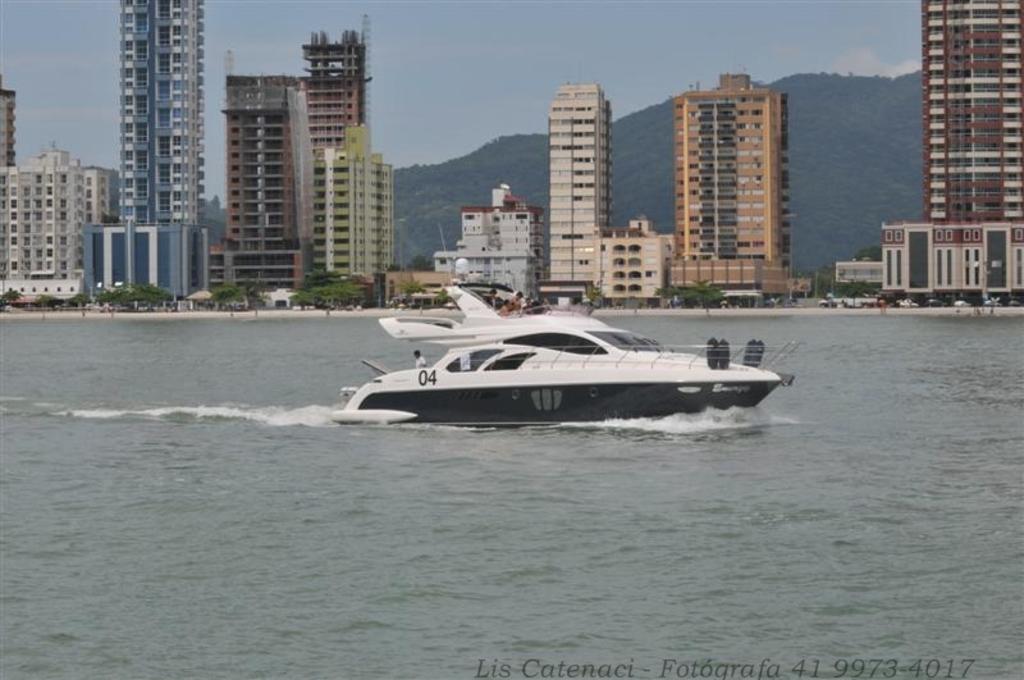Can you describe this image briefly? In this image, we can see water, at the middle there is a black and white color boat, in the background there are some buildings and at the top there is a sky. 